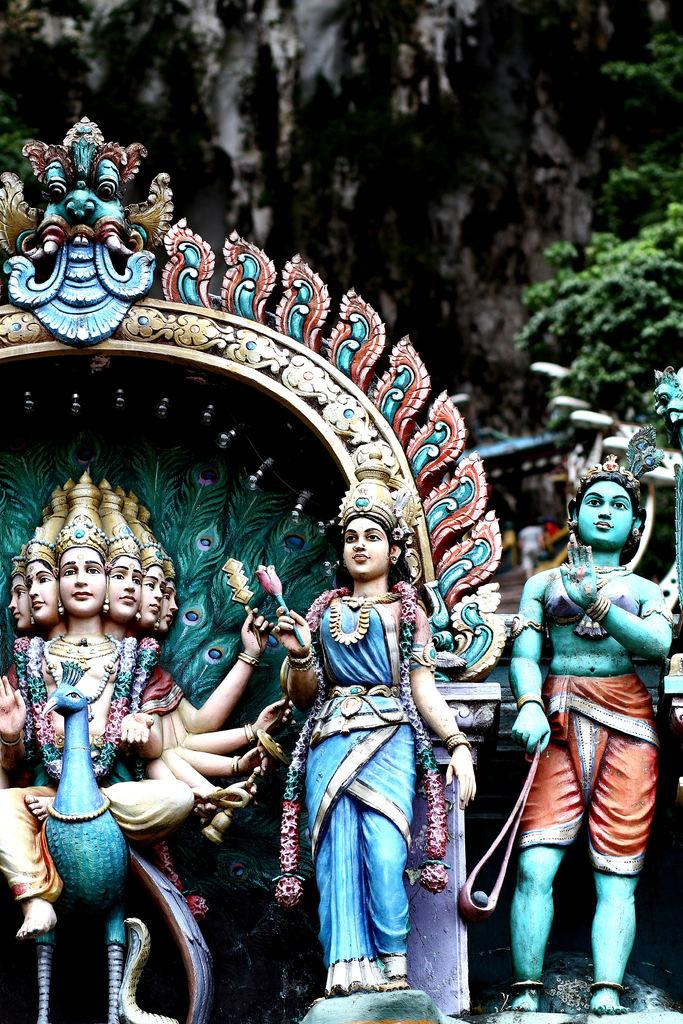What type of objects are present in the image? There are colorful idols in the image. What natural elements can be seen in the image? Leaves of a tree are visible at the top of the image. What type of structure is visible in the image? There is a wall visible in the image. What type of toothpaste is being used to paint the idols in the image? There is no toothpaste present in the image, and the idols are not being painted. 